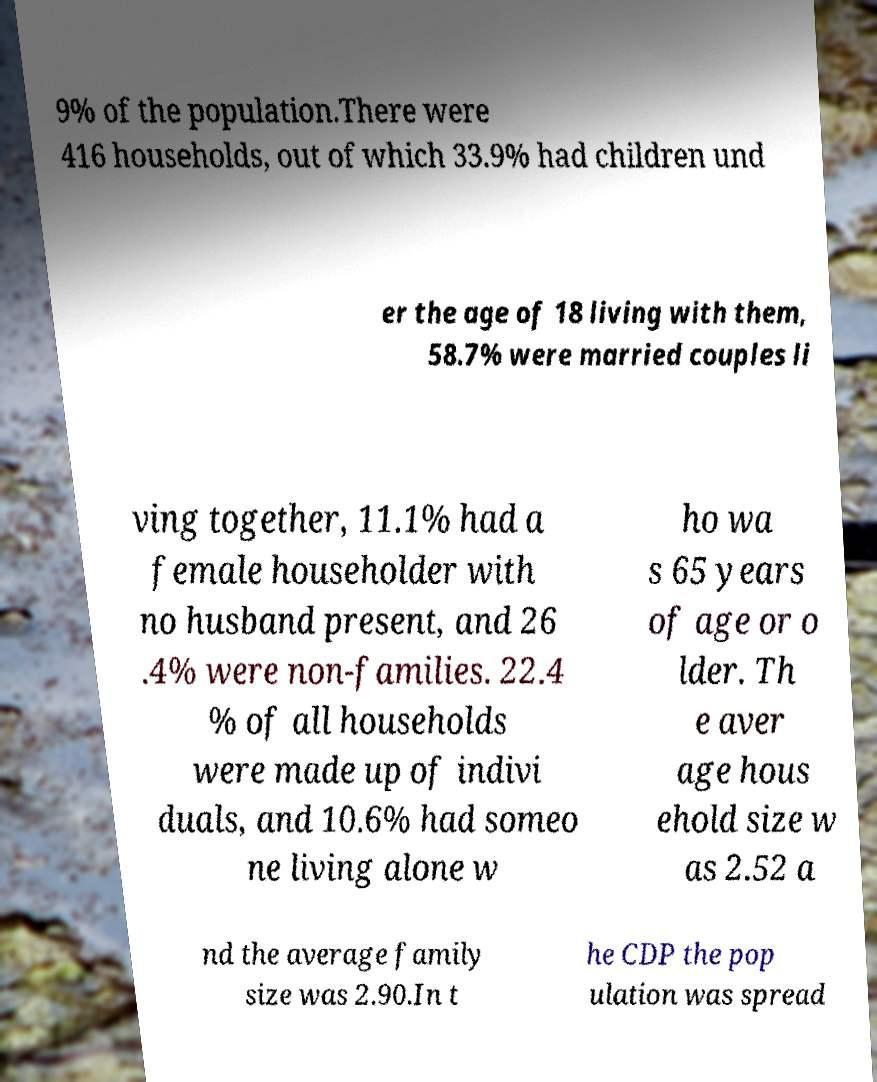I need the written content from this picture converted into text. Can you do that? 9% of the population.There were 416 households, out of which 33.9% had children und er the age of 18 living with them, 58.7% were married couples li ving together, 11.1% had a female householder with no husband present, and 26 .4% were non-families. 22.4 % of all households were made up of indivi duals, and 10.6% had someo ne living alone w ho wa s 65 years of age or o lder. Th e aver age hous ehold size w as 2.52 a nd the average family size was 2.90.In t he CDP the pop ulation was spread 